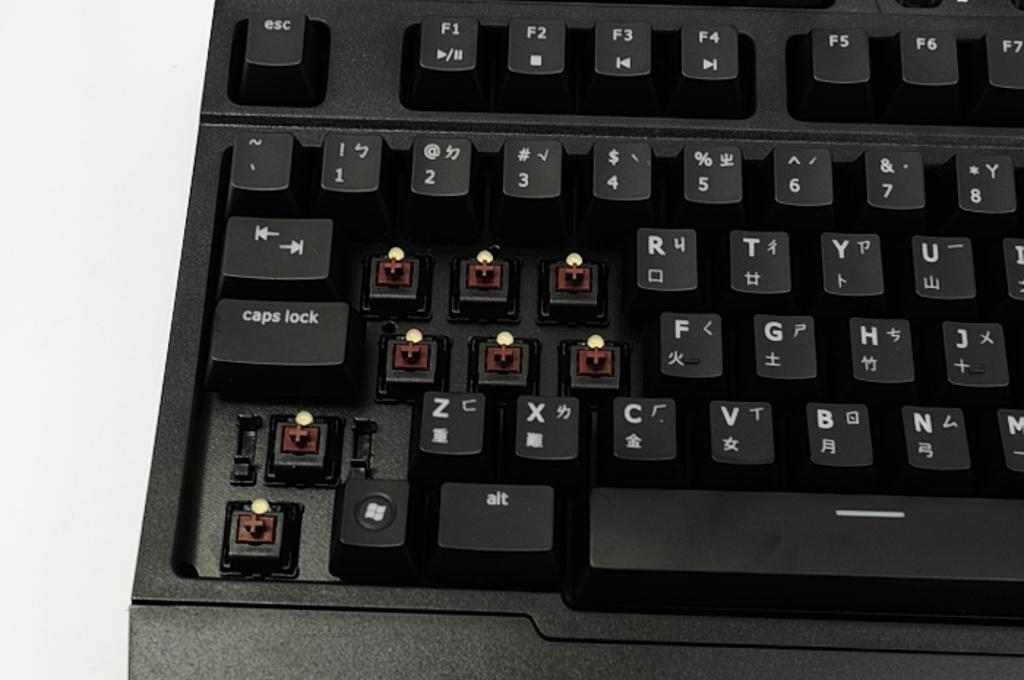<image>
Offer a succinct explanation of the picture presented. A keyboard with missing keys, the caps lock key is still present. 